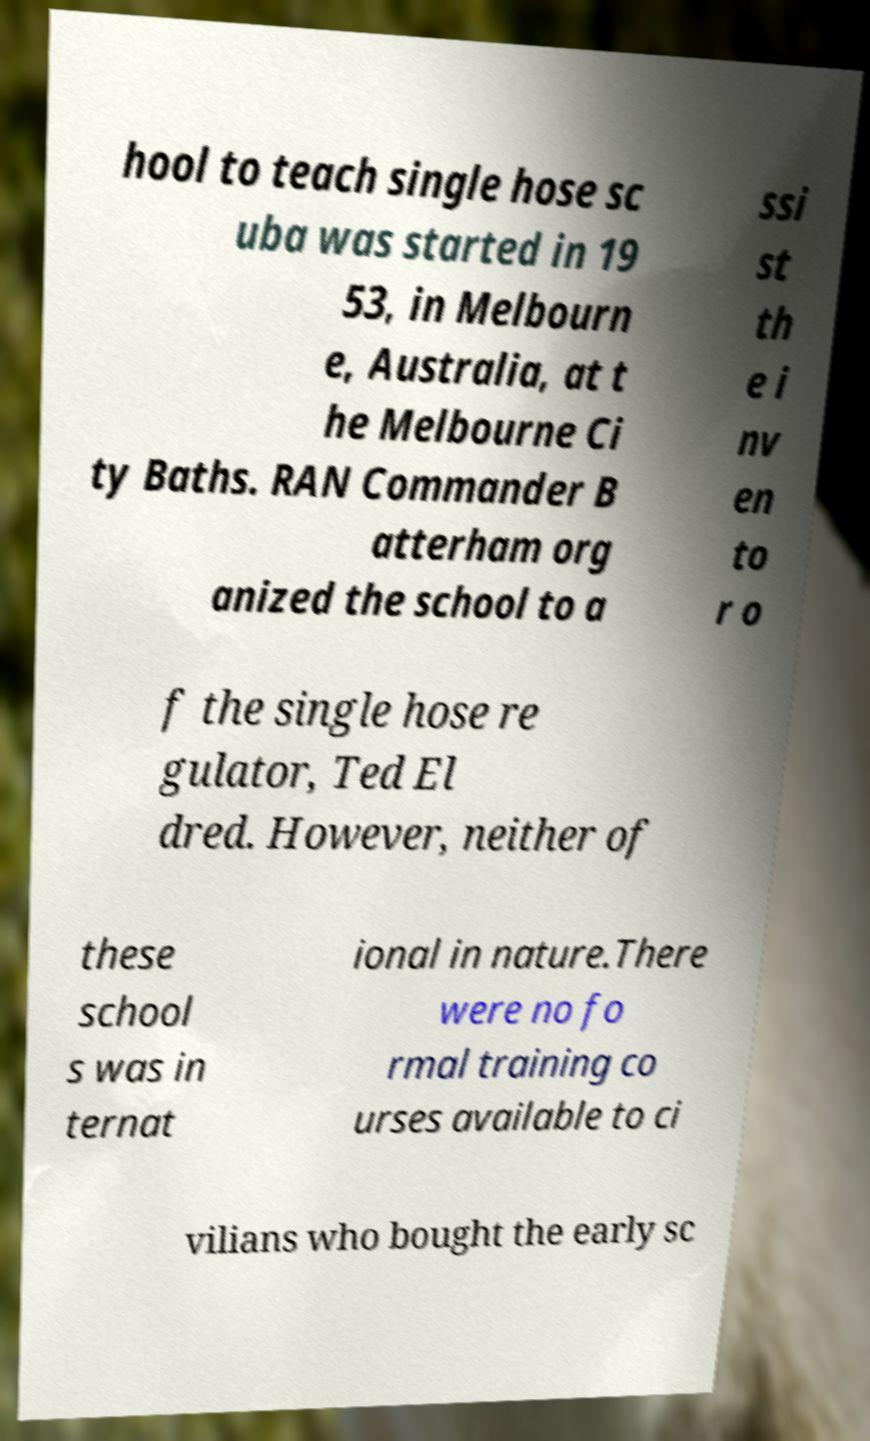I need the written content from this picture converted into text. Can you do that? hool to teach single hose sc uba was started in 19 53, in Melbourn e, Australia, at t he Melbourne Ci ty Baths. RAN Commander B atterham org anized the school to a ssi st th e i nv en to r o f the single hose re gulator, Ted El dred. However, neither of these school s was in ternat ional in nature.There were no fo rmal training co urses available to ci vilians who bought the early sc 